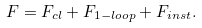<formula> <loc_0><loc_0><loc_500><loc_500>F = F _ { c l } + F _ { 1 - l o o p } + F _ { i n s t } .</formula> 